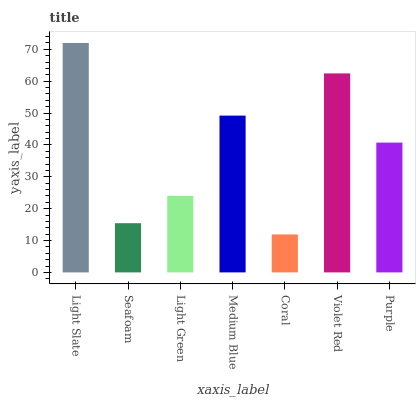Is Coral the minimum?
Answer yes or no. Yes. Is Light Slate the maximum?
Answer yes or no. Yes. Is Seafoam the minimum?
Answer yes or no. No. Is Seafoam the maximum?
Answer yes or no. No. Is Light Slate greater than Seafoam?
Answer yes or no. Yes. Is Seafoam less than Light Slate?
Answer yes or no. Yes. Is Seafoam greater than Light Slate?
Answer yes or no. No. Is Light Slate less than Seafoam?
Answer yes or no. No. Is Purple the high median?
Answer yes or no. Yes. Is Purple the low median?
Answer yes or no. Yes. Is Coral the high median?
Answer yes or no. No. Is Medium Blue the low median?
Answer yes or no. No. 